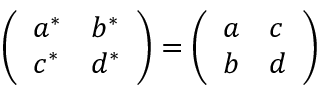<formula> <loc_0><loc_0><loc_500><loc_500>\left ( \begin{array} { l l } { { a ^ { * } } } & { { b ^ { * } } } \\ { { c ^ { * } } } & { { d ^ { * } } } \end{array} \right ) = \left ( \begin{array} { l l } { a } & { c } \\ { b } & { d } \end{array} \right )</formula> 